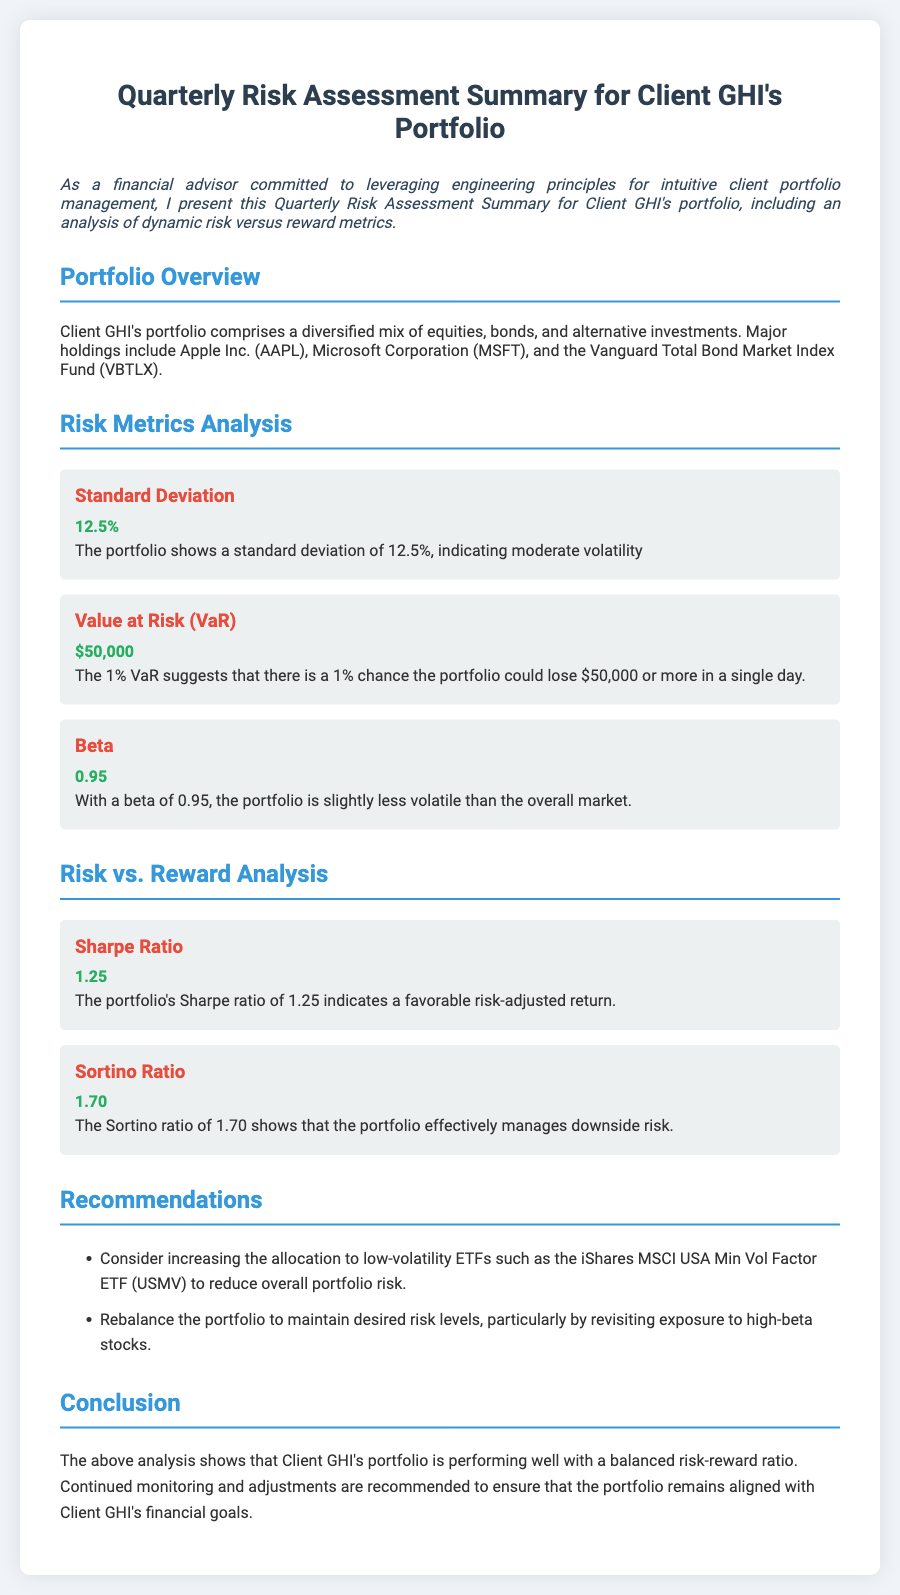What is the standard deviation of the portfolio? The standard deviation is mentioned in the document as a measure of volatility, which is 12.5%.
Answer: 12.5% What is the Value at Risk (VaR) for the portfolio? The VaR indicates the potential loss in value, which is given as $50,000.
Answer: $50,000 What is the beta of Client GHI's portfolio? The document states that the beta of the portfolio is 0.95, indicating its volatility relative to the market.
Answer: 0.95 What is the Sharpe ratio of the portfolio? The Sharpe ratio is a measure of risk-adjusted return, and it is reported as 1.25 in the document.
Answer: 1.25 What recommendation is made regarding low-volatility ETFs? The document suggests considering an increase in allocation to low-volatility ETFs like the iShares MSCI USA Min Vol Factor ETF (USMV).
Answer: iShares MSCI USA Min Vol Factor ETF (USMV) Why should the portfolio be rebalanced? The document notes a need to rebalance the portfolio to maintain desired risk levels, especially concerning high-beta stocks.
Answer: To maintain desired risk levels What does the conclusion suggest about the portfolio's performance? The conclusion states that the portfolio is performing well with a balanced risk-reward ratio.
Answer: Performing well with a balanced risk-reward ratio What type of investments does Client GHI's portfolio include? The document specifies that the portfolio consists of equities, bonds, and alternative investments.
Answer: Equities, bonds, and alternative investments What is the Sortino ratio of the portfolio? The Sortino ratio, which indicates effective management of downside risk, is provided as 1.70 in the document.
Answer: 1.70 